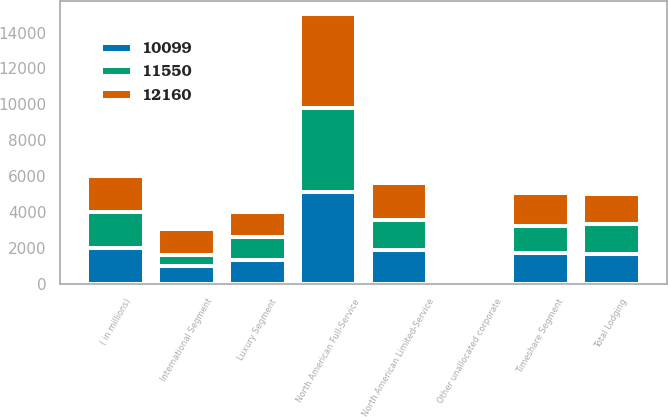Convert chart. <chart><loc_0><loc_0><loc_500><loc_500><stacked_bar_chart><ecel><fcel>( in millions)<fcel>North American Full-Service<fcel>North American Limited-Service<fcel>International Segment<fcel>Luxury Segment<fcel>Timeshare Segment<fcel>Total Lodging<fcel>Other unallocated corporate<nl><fcel>12160<fcel>2006<fcel>5196<fcel>2060<fcel>1411<fcel>1423<fcel>1840<fcel>1673<fcel>65<nl><fcel>10099<fcel>2005<fcel>5116<fcel>1886<fcel>1017<fcel>1333<fcel>1721<fcel>1673<fcel>56<nl><fcel>11550<fcel>2004<fcel>4691<fcel>1673<fcel>604<fcel>1263<fcel>1502<fcel>1673<fcel>45<nl></chart> 